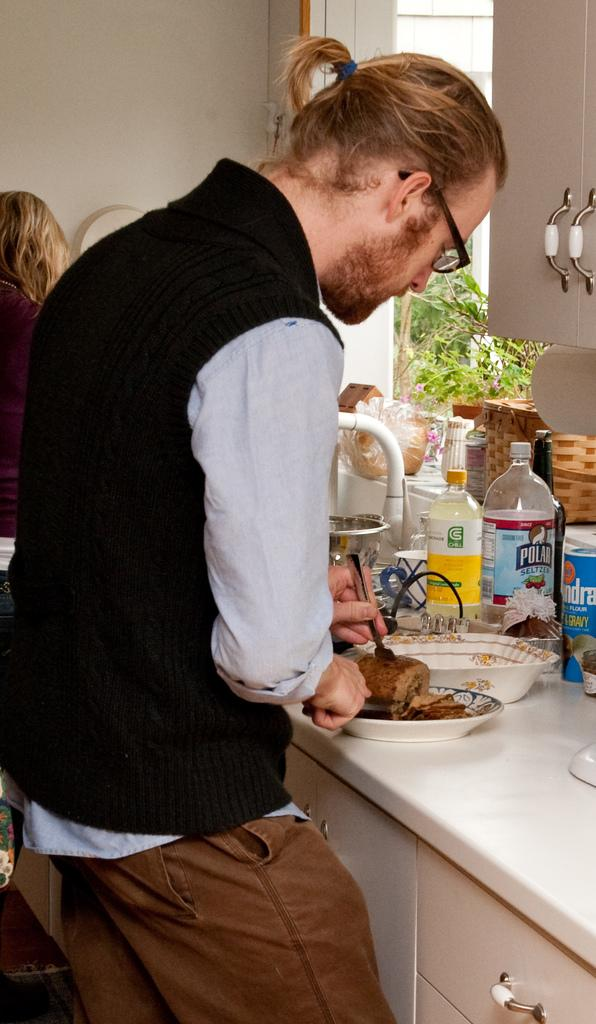Provide a one-sentence caption for the provided image. A man cuts food at a counter that also has a bottle of Polar Seltzer and Chill Lemonade on it. 